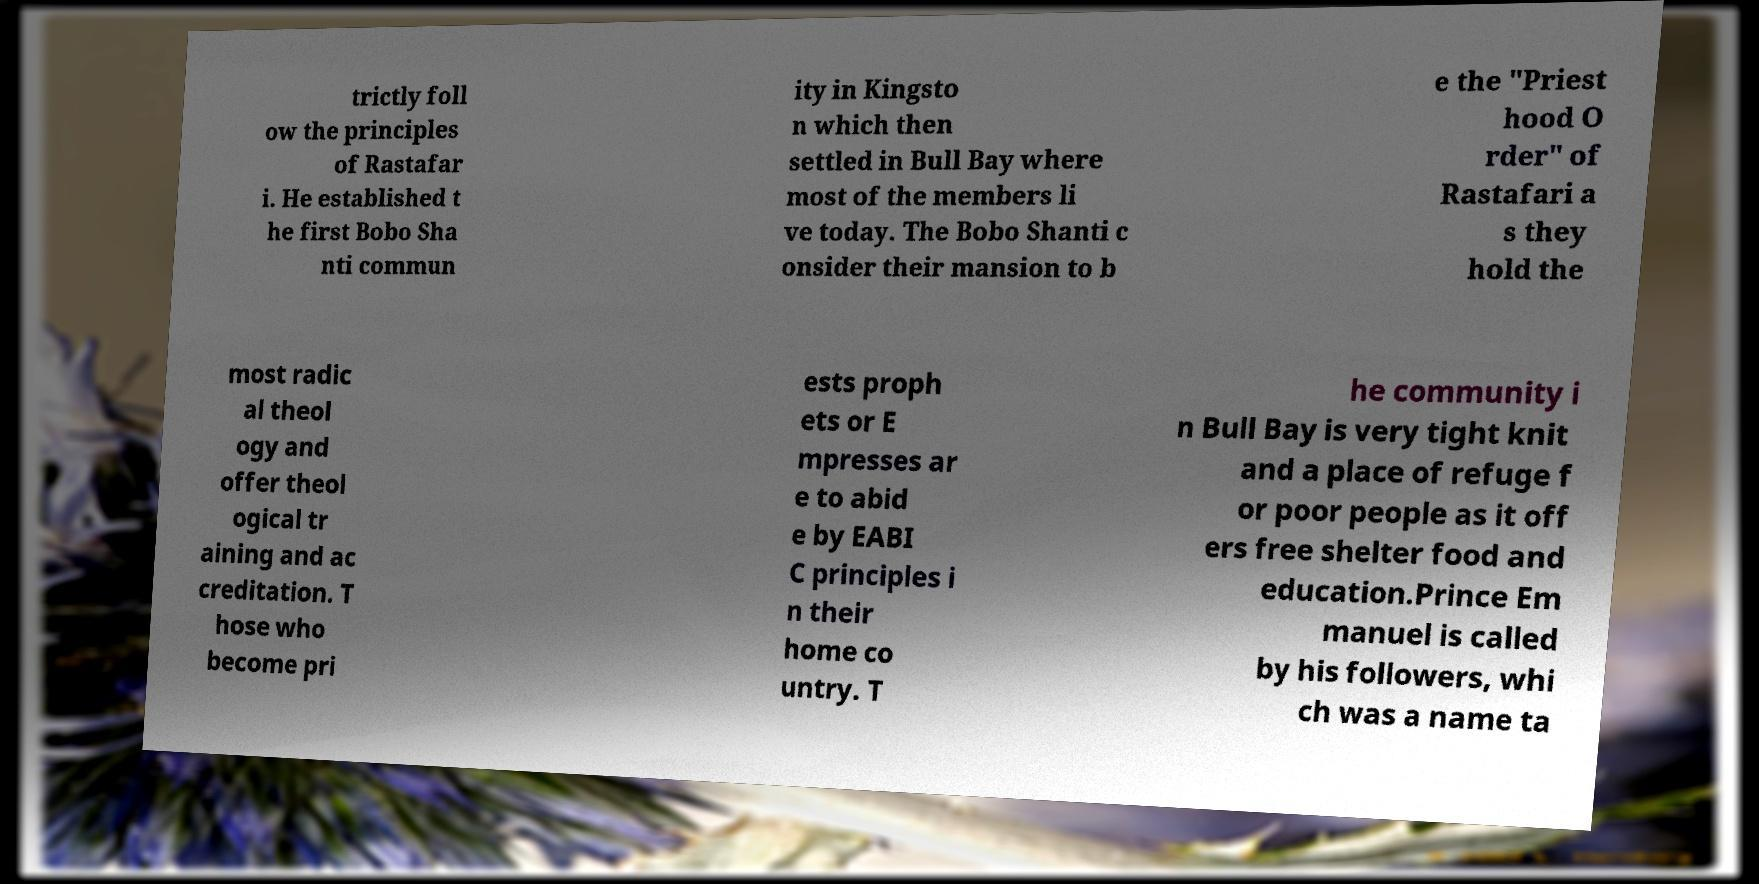Please read and relay the text visible in this image. What does it say? trictly foll ow the principles of Rastafar i. He established t he first Bobo Sha nti commun ity in Kingsto n which then settled in Bull Bay where most of the members li ve today. The Bobo Shanti c onsider their mansion to b e the "Priest hood O rder" of Rastafari a s they hold the most radic al theol ogy and offer theol ogical tr aining and ac creditation. T hose who become pri ests proph ets or E mpresses ar e to abid e by EABI C principles i n their home co untry. T he community i n Bull Bay is very tight knit and a place of refuge f or poor people as it off ers free shelter food and education.Prince Em manuel is called by his followers, whi ch was a name ta 